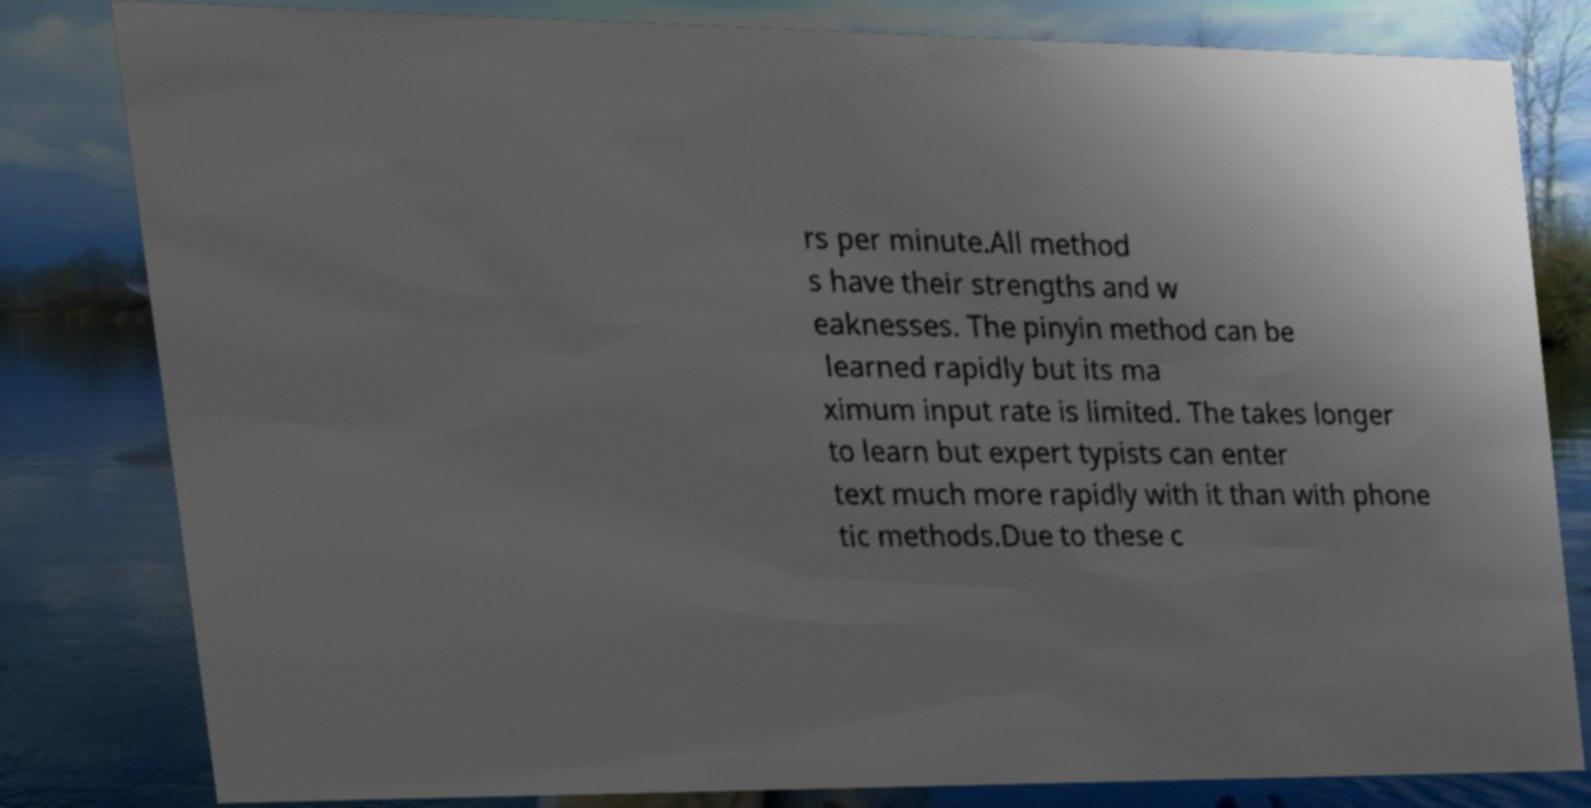Can you read and provide the text displayed in the image?This photo seems to have some interesting text. Can you extract and type it out for me? rs per minute.All method s have their strengths and w eaknesses. The pinyin method can be learned rapidly but its ma ximum input rate is limited. The takes longer to learn but expert typists can enter text much more rapidly with it than with phone tic methods.Due to these c 